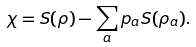Convert formula to latex. <formula><loc_0><loc_0><loc_500><loc_500>\chi = S ( \rho ) - \sum _ { a } p _ { a } S ( \rho _ { a } ) .</formula> 